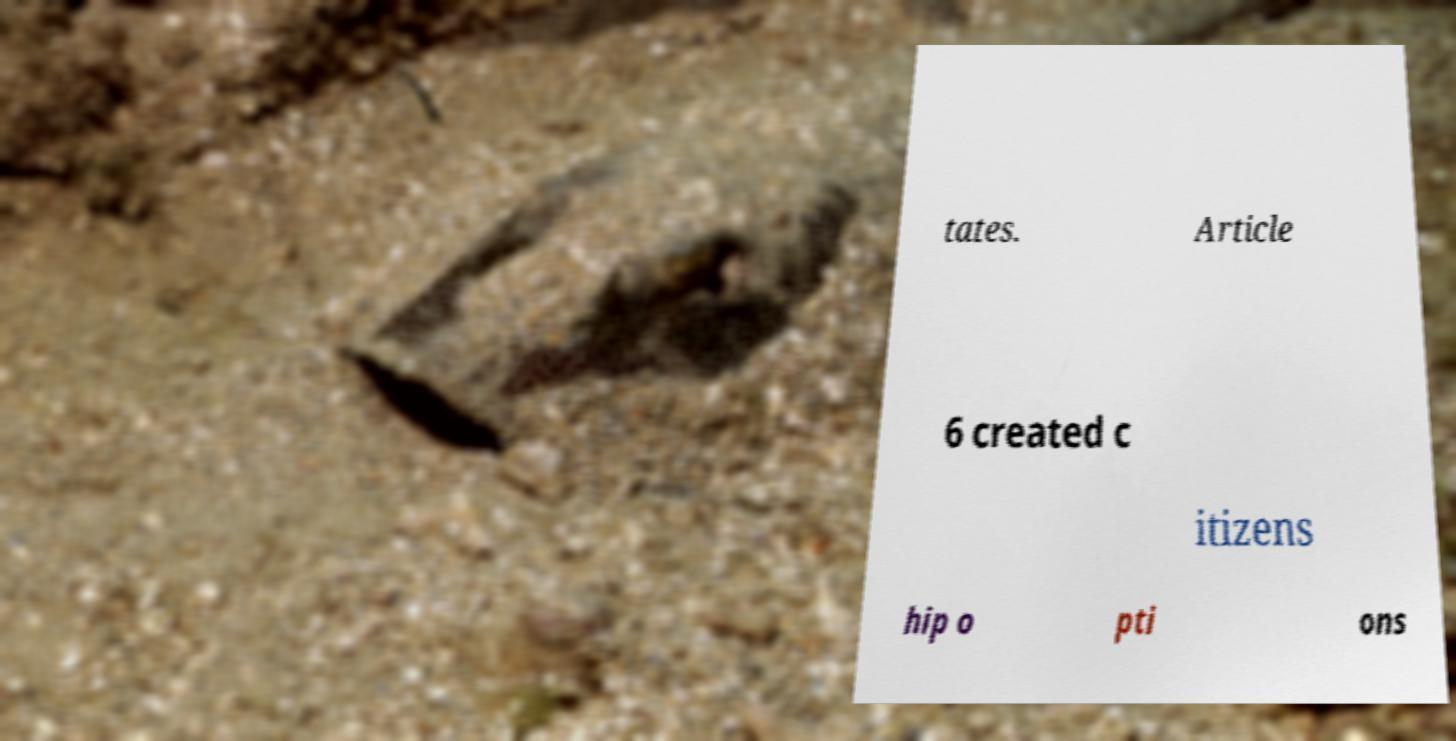There's text embedded in this image that I need extracted. Can you transcribe it verbatim? tates. Article 6 created c itizens hip o pti ons 